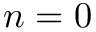<formula> <loc_0><loc_0><loc_500><loc_500>n = 0</formula> 